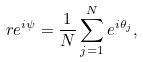Convert formula to latex. <formula><loc_0><loc_0><loc_500><loc_500>r e ^ { i \psi } = \frac { 1 } { N } \sum _ { j = 1 } ^ { N } e ^ { i \theta _ { j } } ,</formula> 